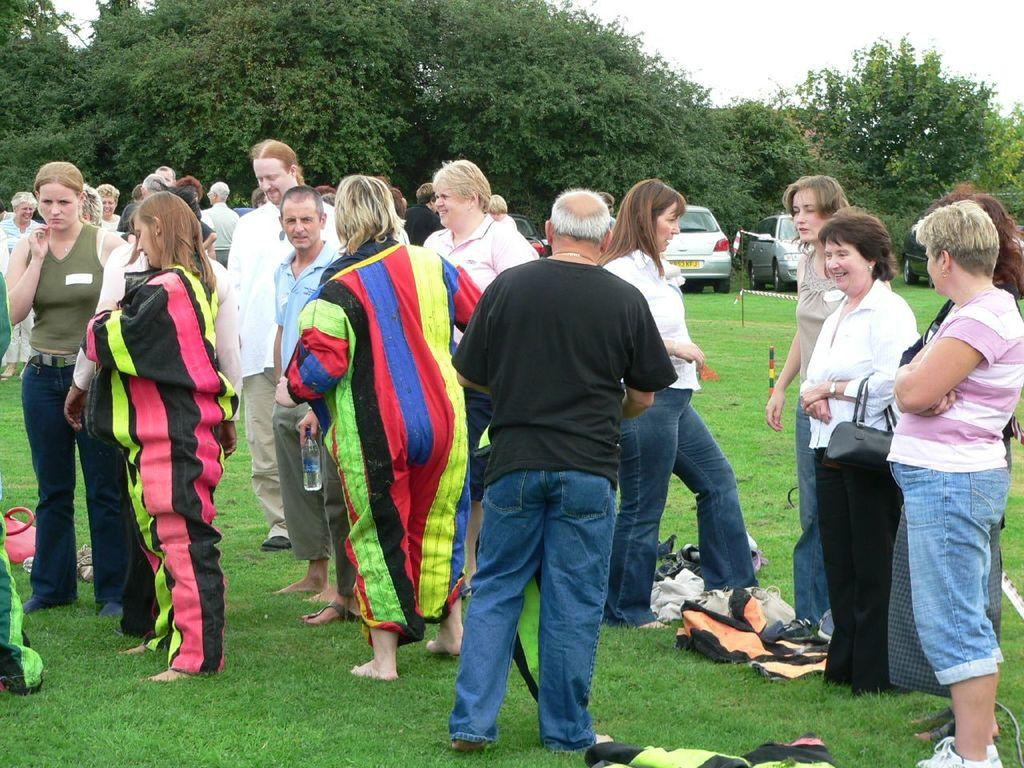How many people can be seen in the image? There are many people standing in the image. What is on the ground in the image? There is grass on the ground, and there are items on the ground as well. What can be seen in the background of the image? There are vehicles, trees, and the sky visible in the background. How does the level of the grass affect the digestion of the people in the image? The level of the grass does not affect the digestion of the people in the image, as there is no information provided about the grass's height or the people's digestion. 